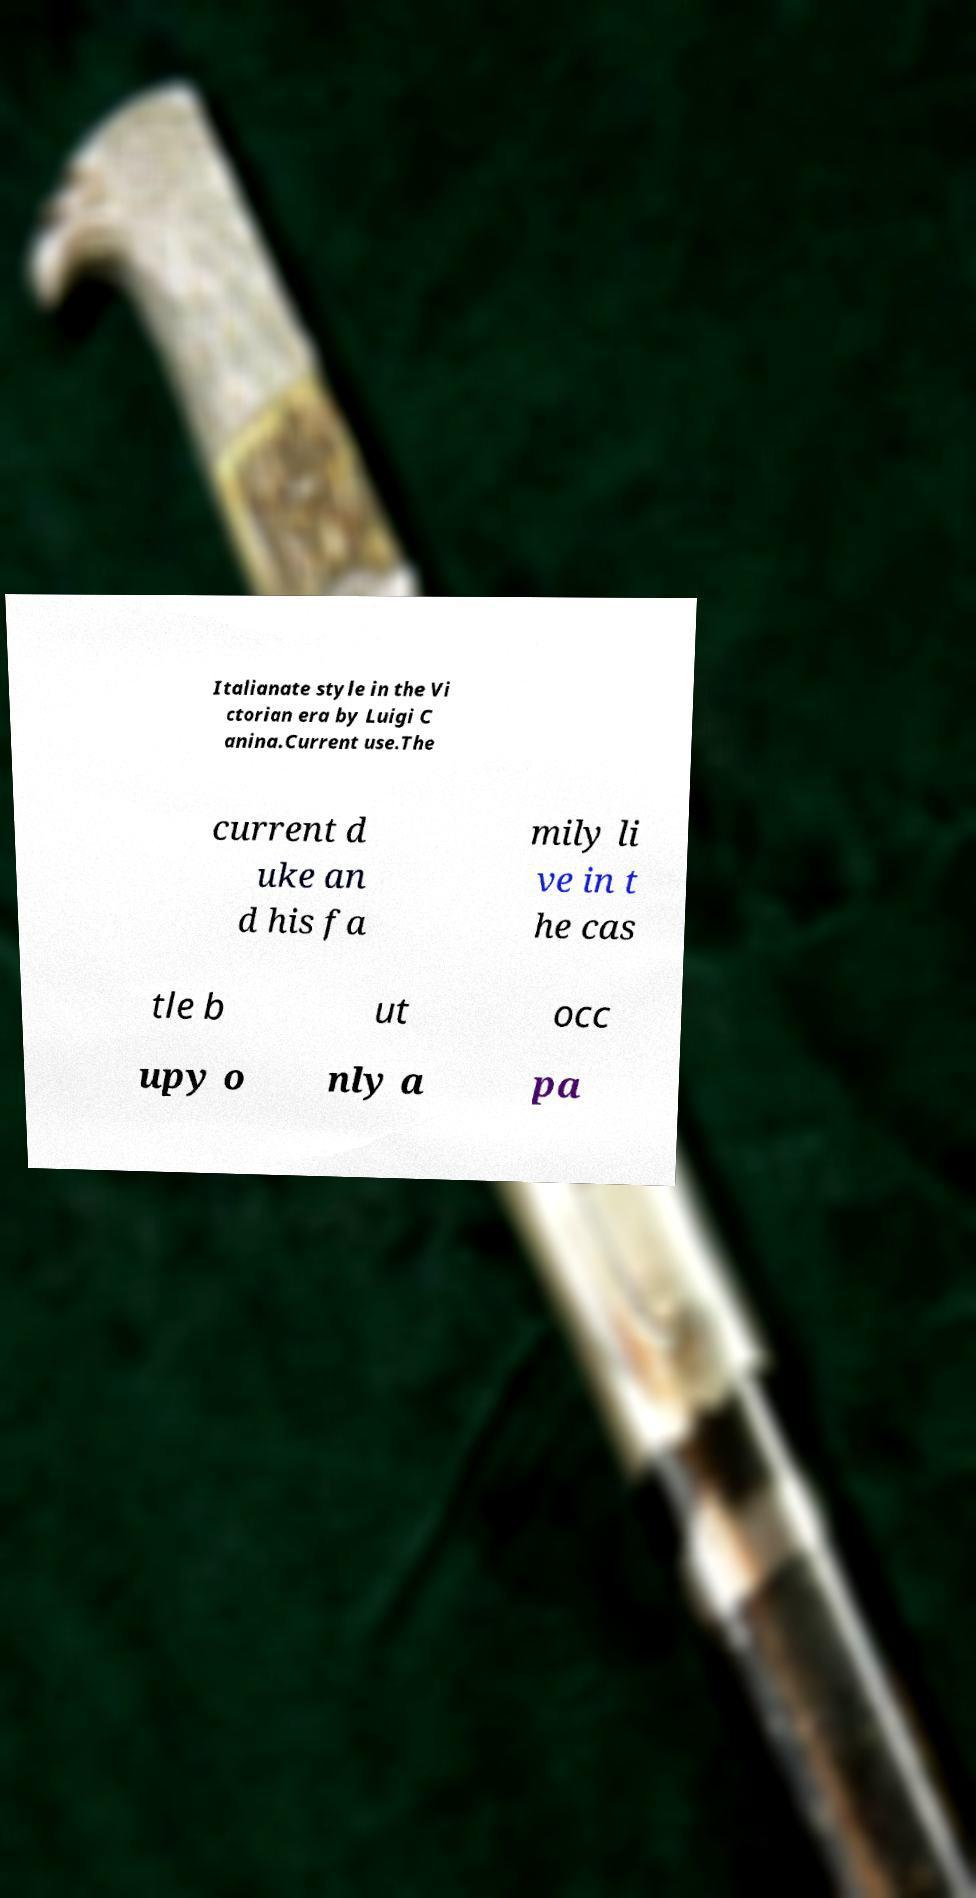For documentation purposes, I need the text within this image transcribed. Could you provide that? Italianate style in the Vi ctorian era by Luigi C anina.Current use.The current d uke an d his fa mily li ve in t he cas tle b ut occ upy o nly a pa 